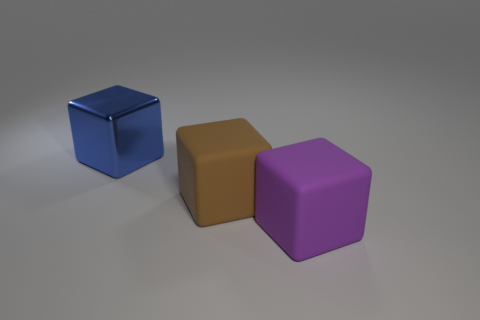Add 2 brown matte things. How many objects exist? 5 Add 3 large matte blocks. How many large matte blocks exist? 5 Subtract 0 yellow cubes. How many objects are left? 3 Subtract all blue objects. Subtract all rubber objects. How many objects are left? 0 Add 2 brown rubber things. How many brown rubber things are left? 3 